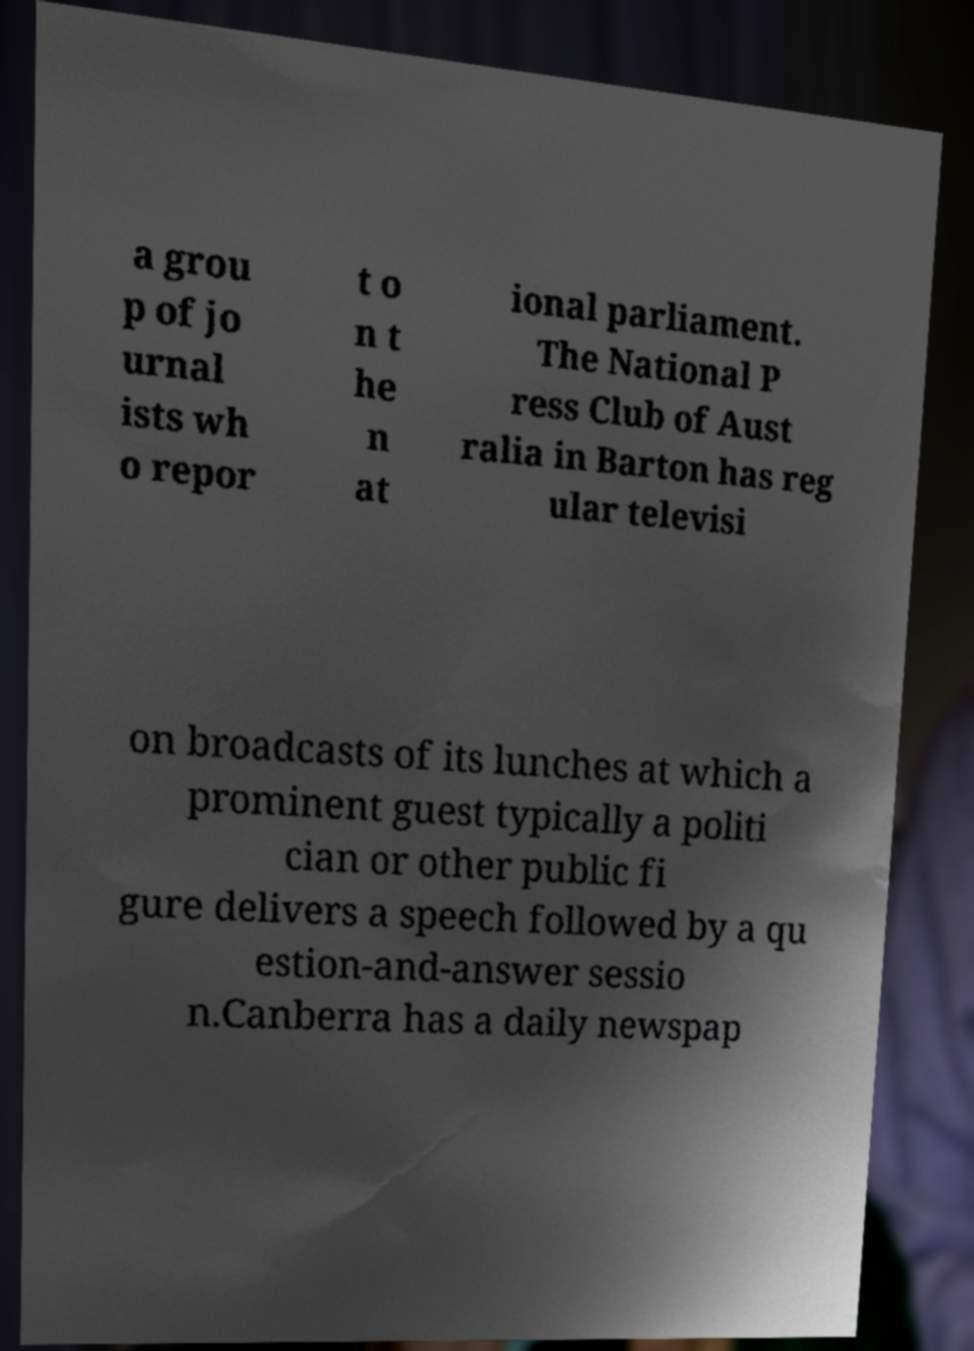Could you extract and type out the text from this image? a grou p of jo urnal ists wh o repor t o n t he n at ional parliament. The National P ress Club of Aust ralia in Barton has reg ular televisi on broadcasts of its lunches at which a prominent guest typically a politi cian or other public fi gure delivers a speech followed by a qu estion-and-answer sessio n.Canberra has a daily newspap 